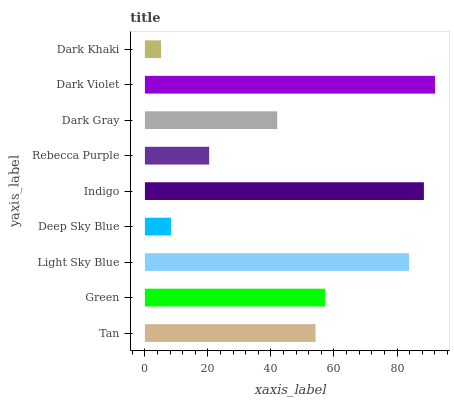Is Dark Khaki the minimum?
Answer yes or no. Yes. Is Dark Violet the maximum?
Answer yes or no. Yes. Is Green the minimum?
Answer yes or no. No. Is Green the maximum?
Answer yes or no. No. Is Green greater than Tan?
Answer yes or no. Yes. Is Tan less than Green?
Answer yes or no. Yes. Is Tan greater than Green?
Answer yes or no. No. Is Green less than Tan?
Answer yes or no. No. Is Tan the high median?
Answer yes or no. Yes. Is Tan the low median?
Answer yes or no. Yes. Is Dark Gray the high median?
Answer yes or no. No. Is Light Sky Blue the low median?
Answer yes or no. No. 